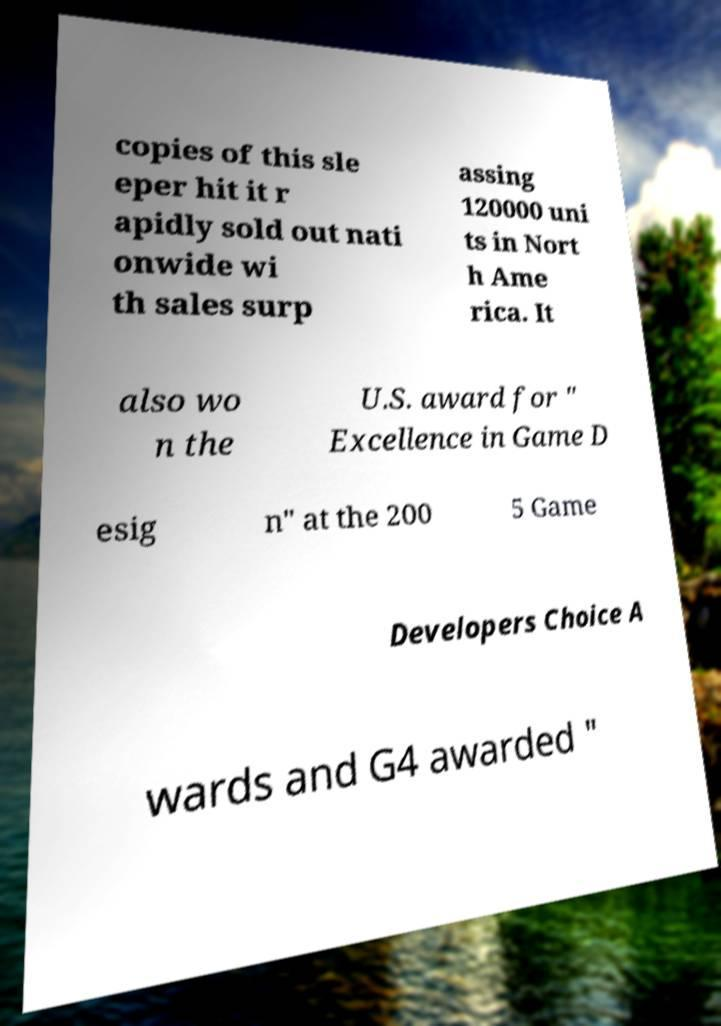For documentation purposes, I need the text within this image transcribed. Could you provide that? copies of this sle eper hit it r apidly sold out nati onwide wi th sales surp assing 120000 uni ts in Nort h Ame rica. It also wo n the U.S. award for " Excellence in Game D esig n" at the 200 5 Game Developers Choice A wards and G4 awarded " 